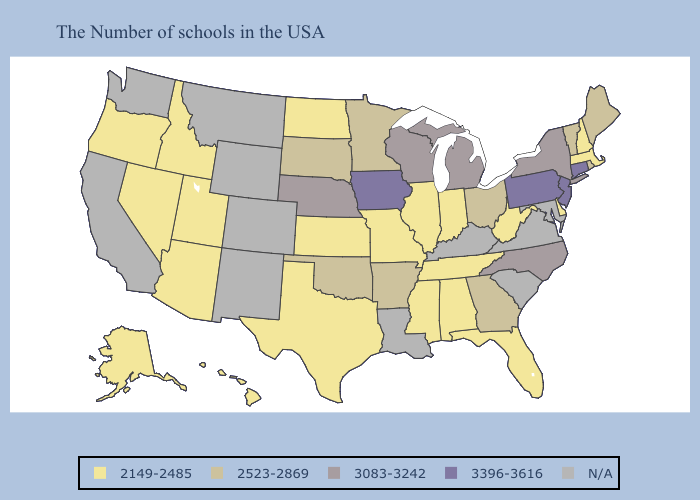Does the first symbol in the legend represent the smallest category?
Short answer required. Yes. Does Delaware have the highest value in the South?
Concise answer only. No. Does New Hampshire have the highest value in the Northeast?
Quick response, please. No. What is the lowest value in the MidWest?
Be succinct. 2149-2485. Does the map have missing data?
Concise answer only. Yes. Name the states that have a value in the range 2523-2869?
Short answer required. Maine, Rhode Island, Vermont, Ohio, Georgia, Arkansas, Minnesota, Oklahoma, South Dakota. Does Arkansas have the highest value in the South?
Give a very brief answer. No. What is the lowest value in the Northeast?
Keep it brief. 2149-2485. Which states have the lowest value in the MidWest?
Quick response, please. Indiana, Illinois, Missouri, Kansas, North Dakota. Does Iowa have the highest value in the MidWest?
Answer briefly. Yes. What is the lowest value in the USA?
Keep it brief. 2149-2485. Does South Dakota have the lowest value in the MidWest?
Write a very short answer. No. 